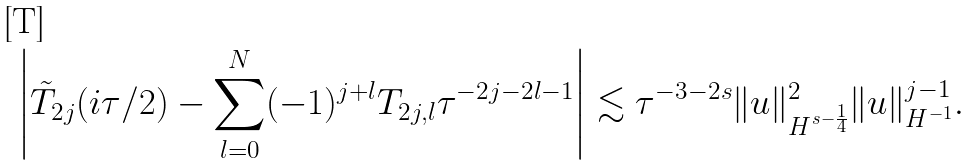<formula> <loc_0><loc_0><loc_500><loc_500>\left | \tilde { T } _ { 2 j } ( i \tau / 2 ) - \sum _ { l = 0 } ^ { N } ( - 1 ) ^ { j + l } T _ { 2 j , l } \tau ^ { - 2 j - 2 l - 1 } \right | \lesssim \tau ^ { - 3 - 2 s } \| u \| _ { H ^ { s - \frac { 1 } { 4 } } } ^ { 2 } \| u \| _ { H ^ { - 1 } } ^ { j - 1 } .</formula> 